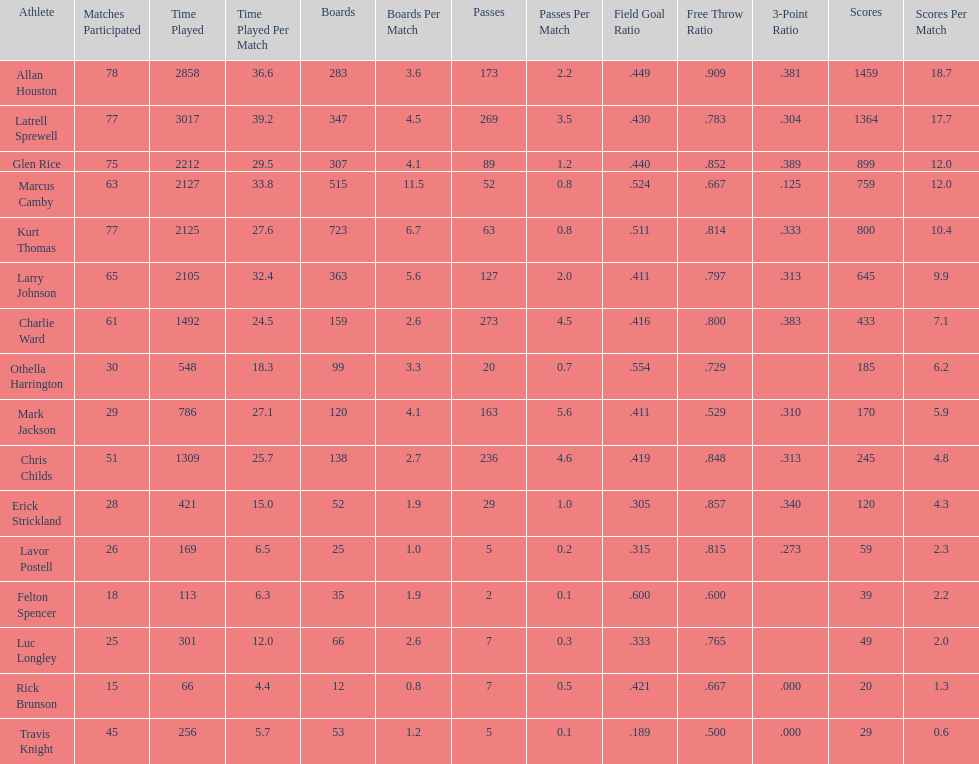Number of players on the team. 16. 